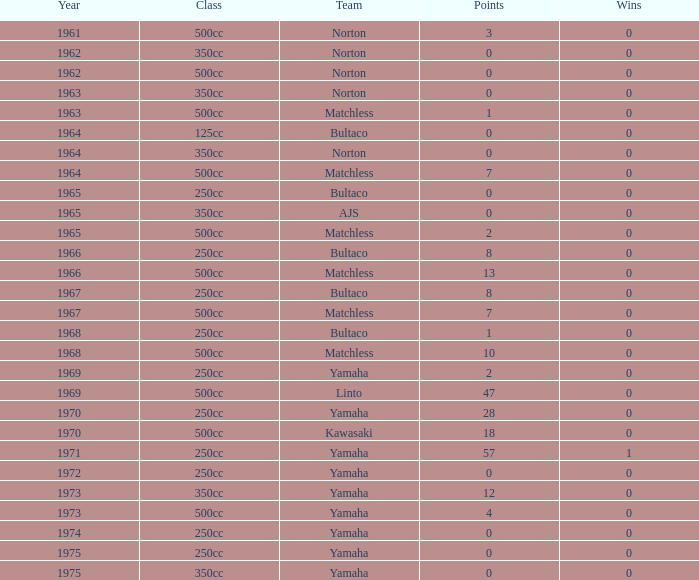In which class does the number of points exceed 2, wins surpass 0, and the year is earlier than 1973? 250cc. 